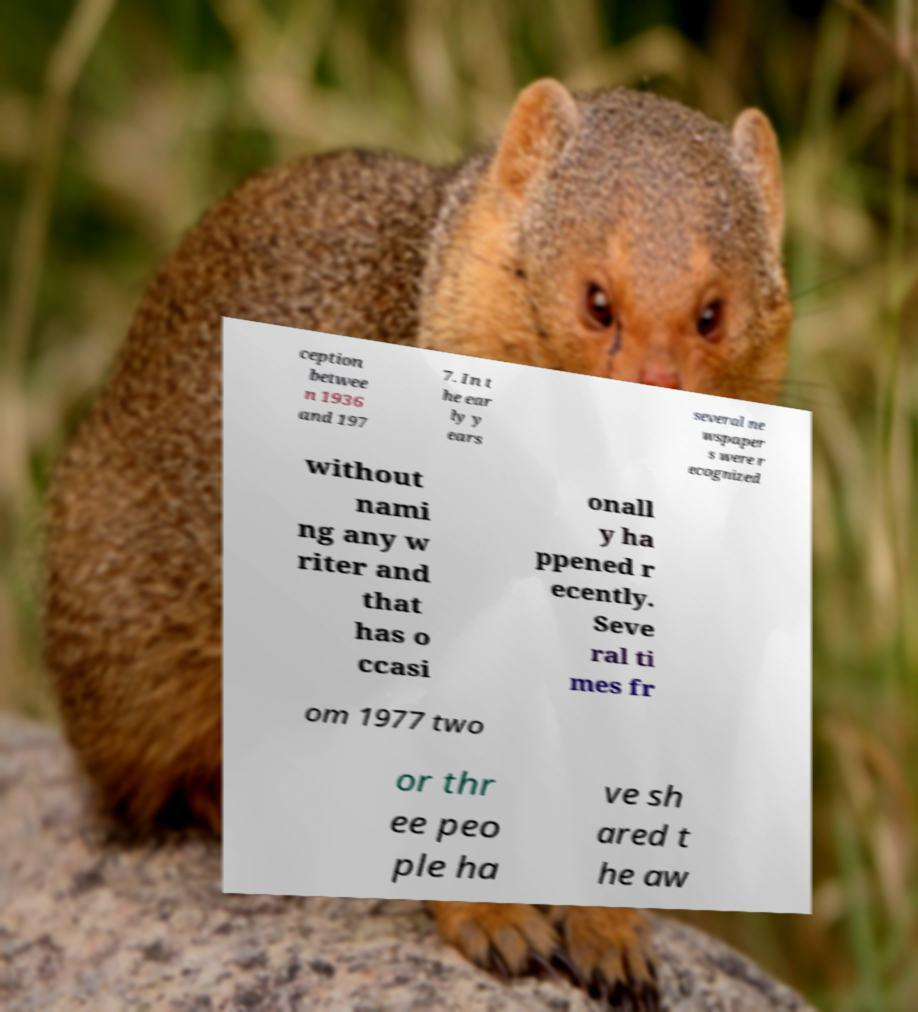For documentation purposes, I need the text within this image transcribed. Could you provide that? ception betwee n 1936 and 197 7. In t he ear ly y ears several ne wspaper s were r ecognized without nami ng any w riter and that has o ccasi onall y ha ppened r ecently. Seve ral ti mes fr om 1977 two or thr ee peo ple ha ve sh ared t he aw 